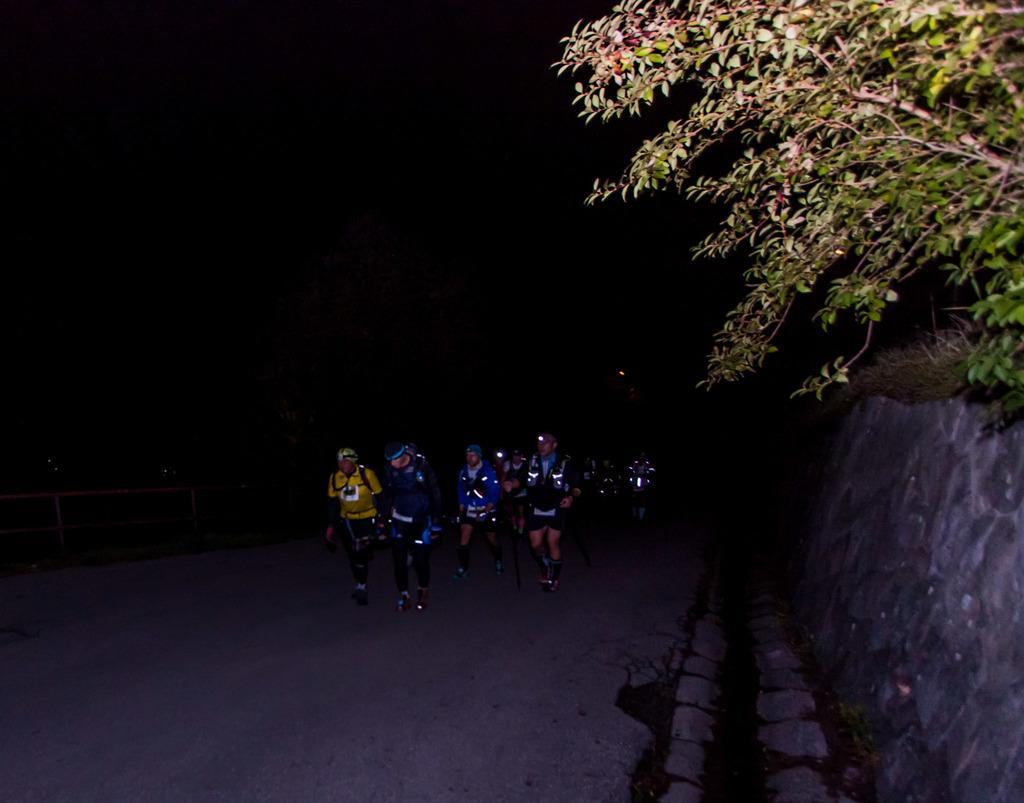How would you summarize this image in a sentence or two? In this picture we can see a group of people wore helmets and walking on the road, trees, wall, fence and in the background it is dark. 